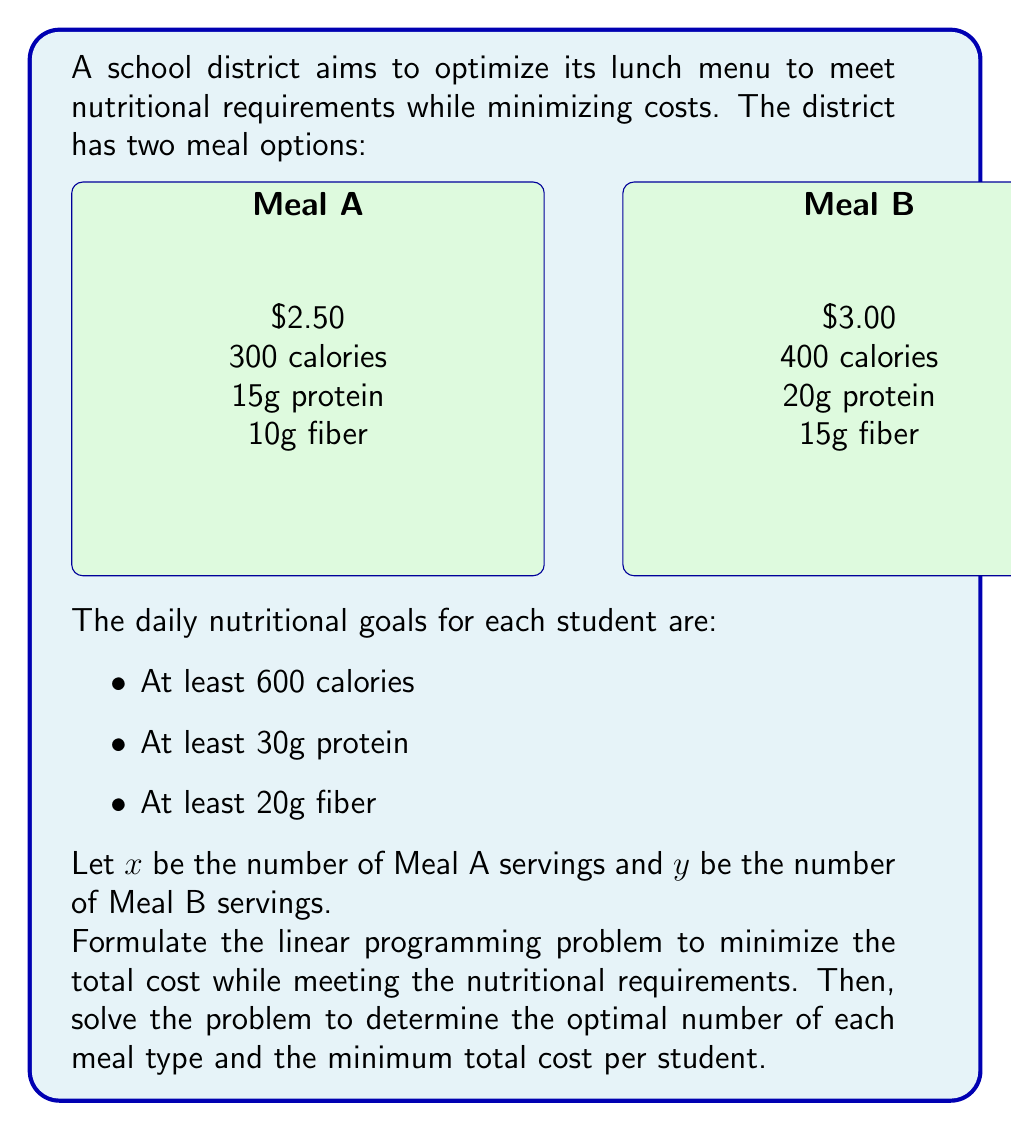Can you answer this question? Step 1: Formulate the linear programming problem

Objective function (minimize cost):
$$\text{Minimize } Z = 2.50x + 3.00y$$

Constraints:
1. Calories: $300x + 400y \geq 600$
2. Protein: $15x + 20y \geq 30$
3. Fiber: $10x + 15y \geq 20$
4. Non-negativity: $x \geq 0, y \geq 0$

Step 2: Solve the problem using the graphical method

Plot the constraints:
1. $300x + 400y = 600 \implies y = 1.5 - 0.75x$
2. $15x + 20y = 30 \implies y = 1.5 - 0.75x$
3. $10x + 15y = 20 \implies y = 1.33 - 0.67x$

The feasible region is the area above all three constraint lines.

Step 3: Identify the vertices of the feasible region

The optimal solution will be at one of the vertices. The vertices are:
A. (2, 0)
B. (0, 1.5)
C. Intersection of constraints 1 and 2: (2, 0)

Step 4: Evaluate the objective function at each vertex

A. $Z(2, 0) = 2.50(2) + 3.00(0) = 5.00$
B. $Z(0, 1.5) = 2.50(0) + 3.00(1.5) = 4.50$
C. Same as A

Step 5: Determine the optimal solution

The minimum cost occurs at vertex B (0, 1.5), which means:
x = 0 (Meal A)
y = 1.5 (Meal B)

The optimal solution is to serve 1.5 portions of Meal B per student, with a total cost of $4.50 per student.
Answer: Serve 1.5 portions of Meal B; Cost: $4.50 per student 